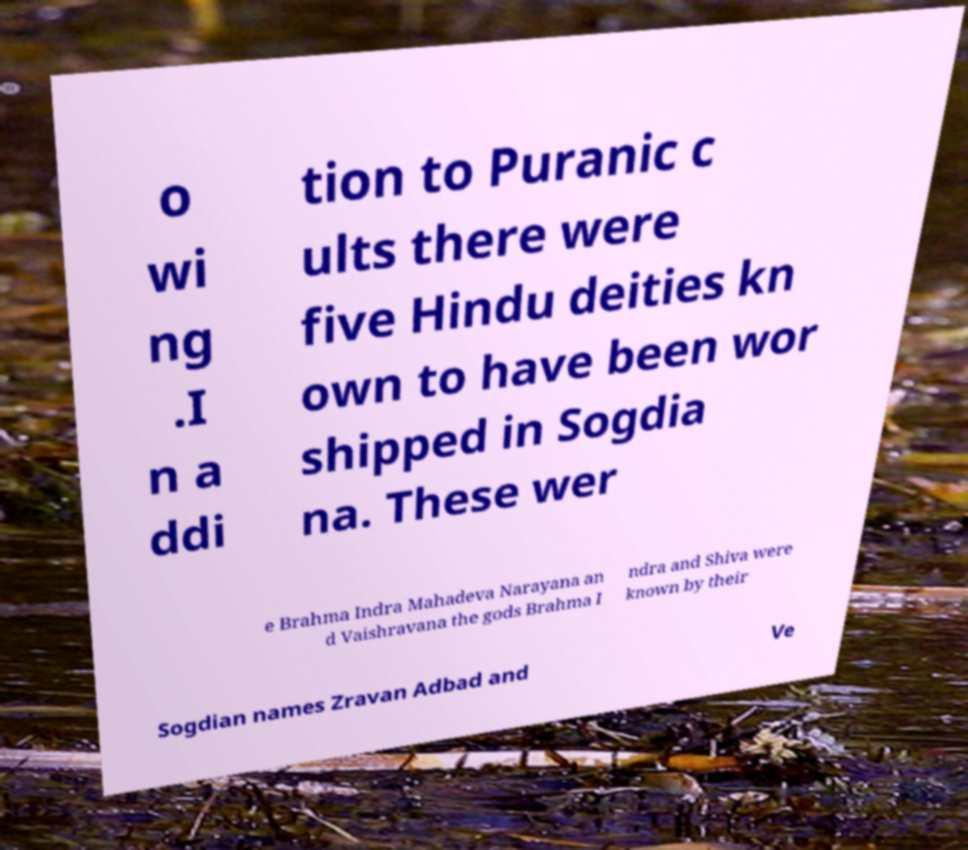Can you accurately transcribe the text from the provided image for me? o wi ng .I n a ddi tion to Puranic c ults there were five Hindu deities kn own to have been wor shipped in Sogdia na. These wer e Brahma Indra Mahadeva Narayana an d Vaishravana the gods Brahma I ndra and Shiva were known by their Sogdian names Zravan Adbad and Ve 